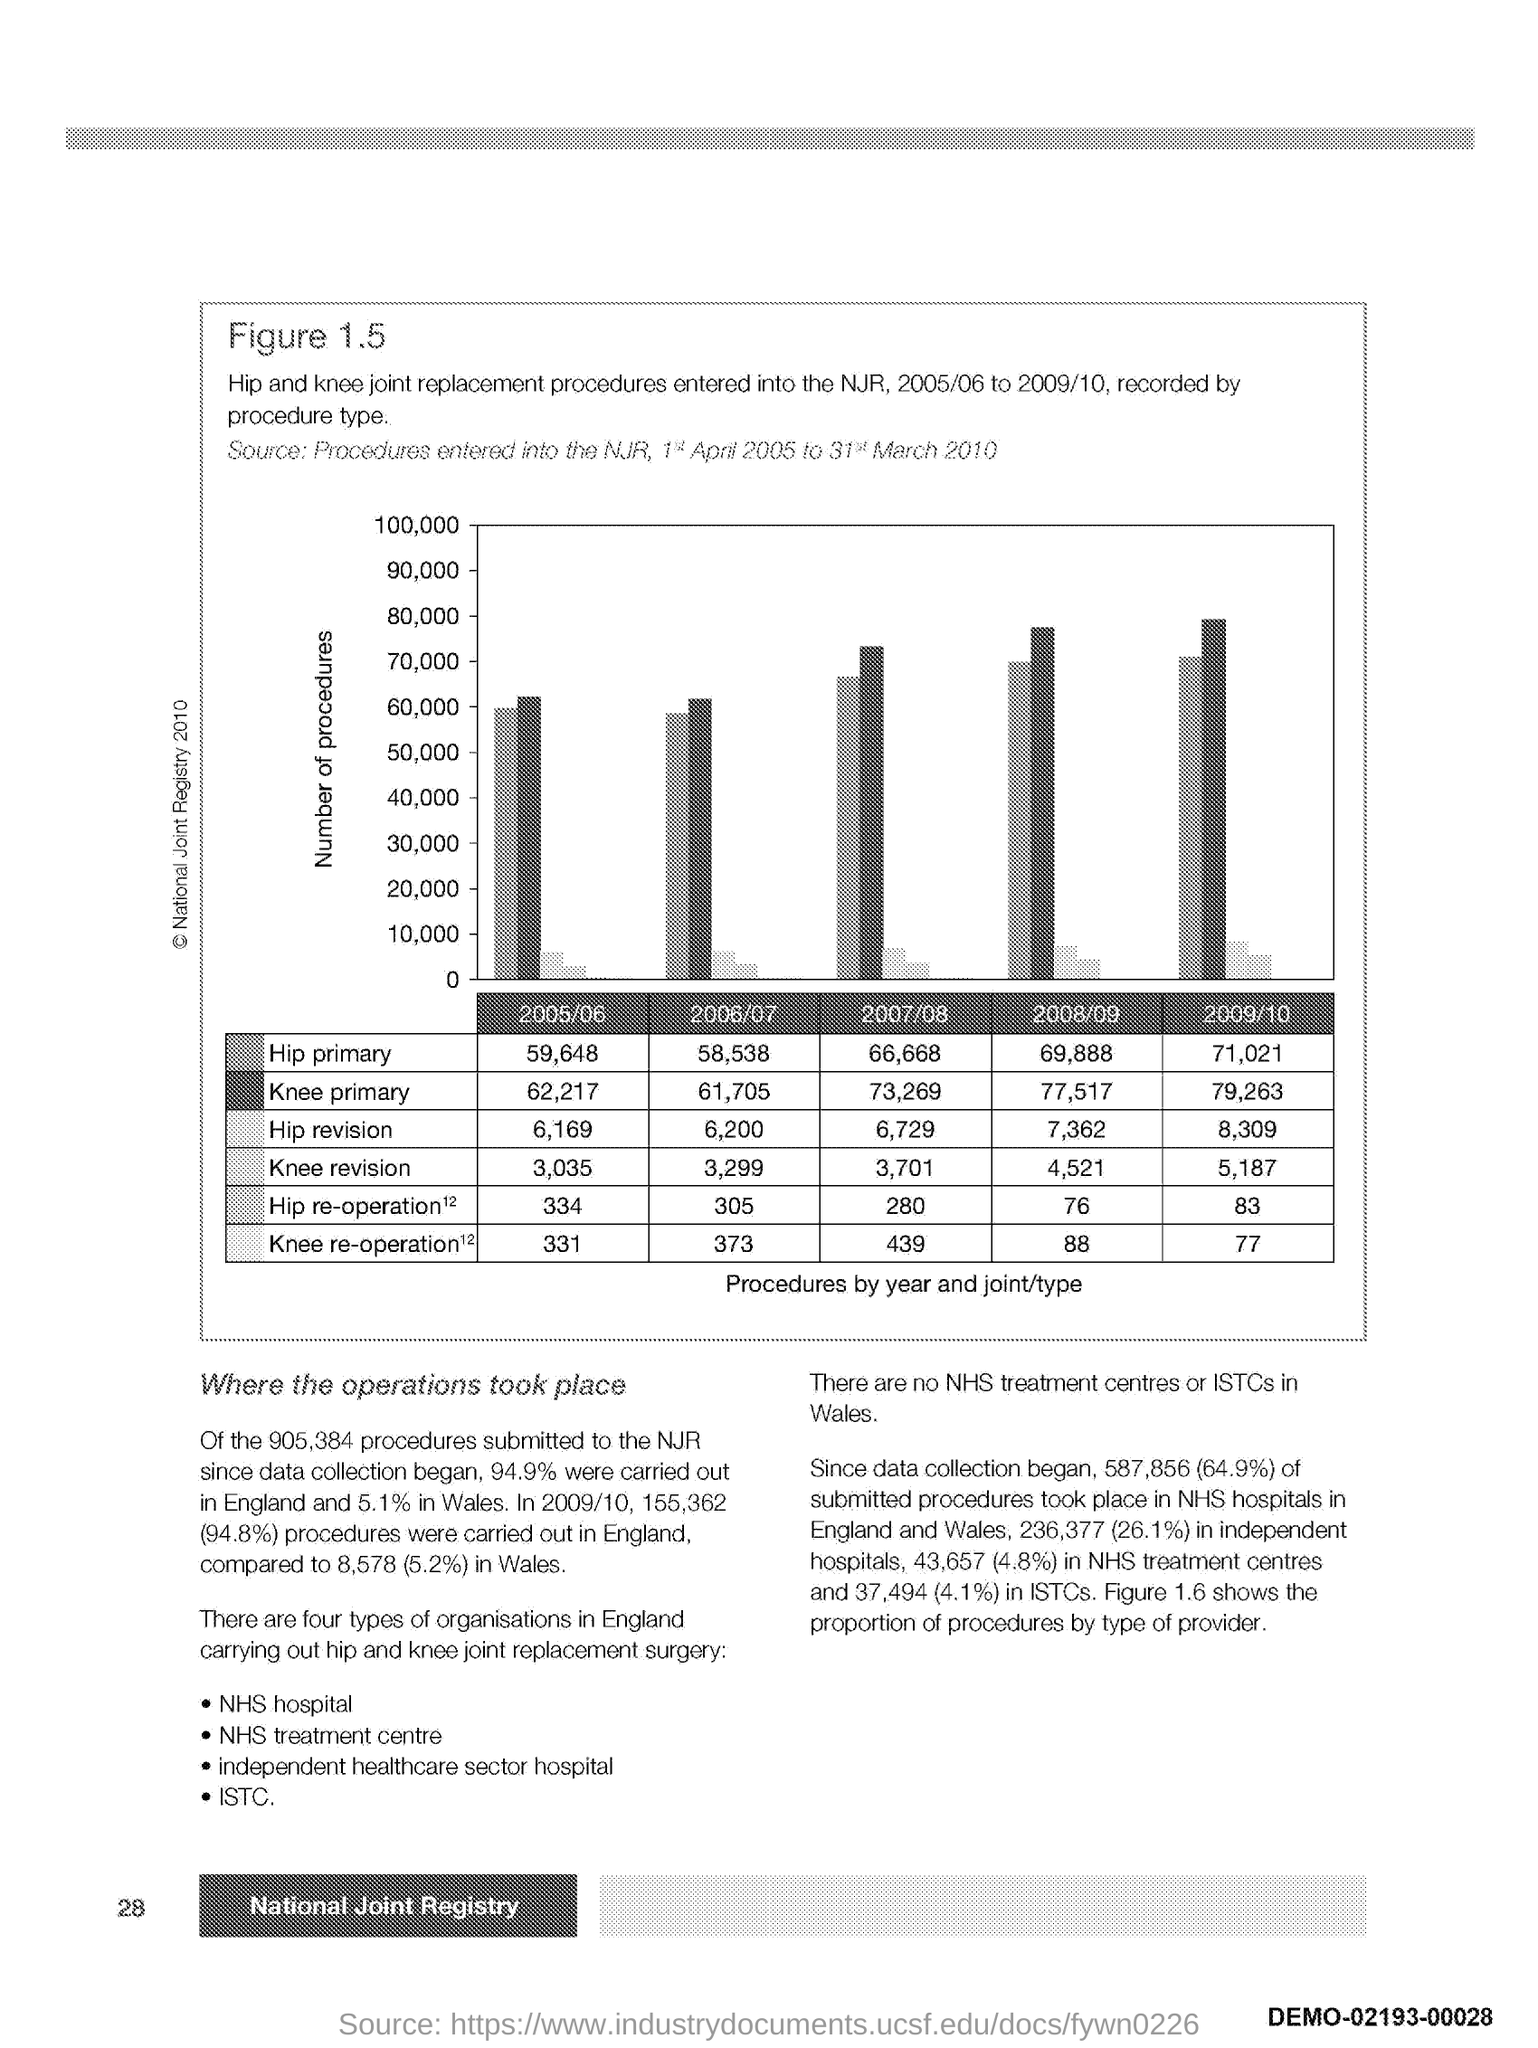Mention a couple of crucial points in this snapshot. In the year 2009/2010, a total of 71,021 hip primary procedures were performed. In the 2006/2007 fiscal year, a total of 61,705 primary knee procedures were performed. In 2006/07, a total of 58,538 hip primary procedures were performed. In the 2005/2006 fiscal year, 62,217 primary knee procedures were performed. In the 2007/2008 fiscal year, a total of 66,668 hip primary procedures were performed. 